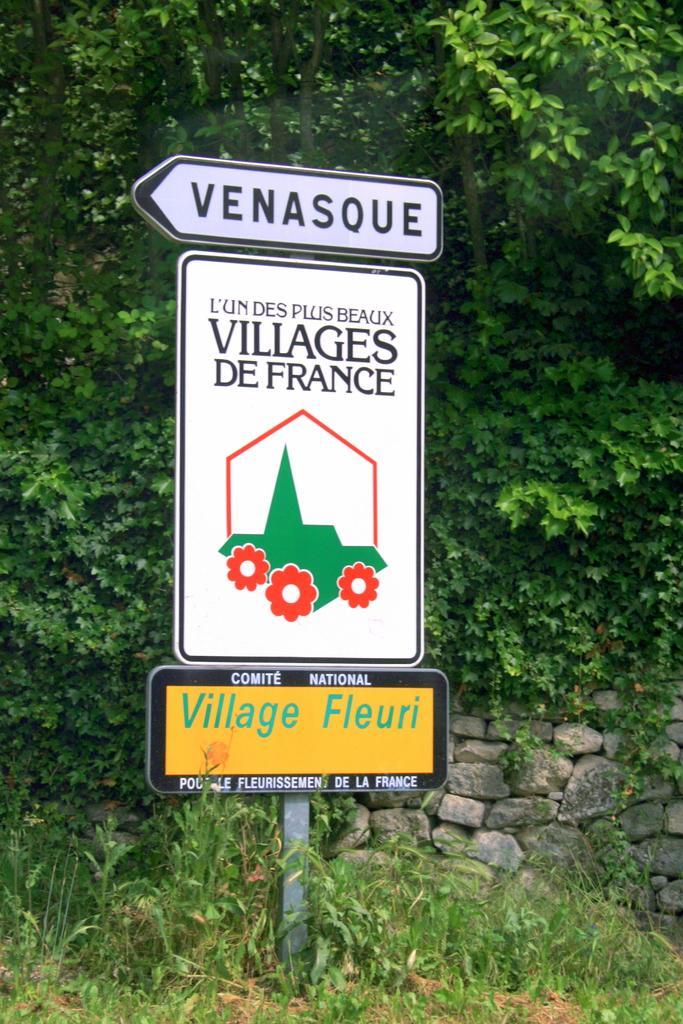Describe this image in one or two sentences. In this image we can see a pole with the boards and there is an image and text written on the image. In the background, we can see the wall and trees. 